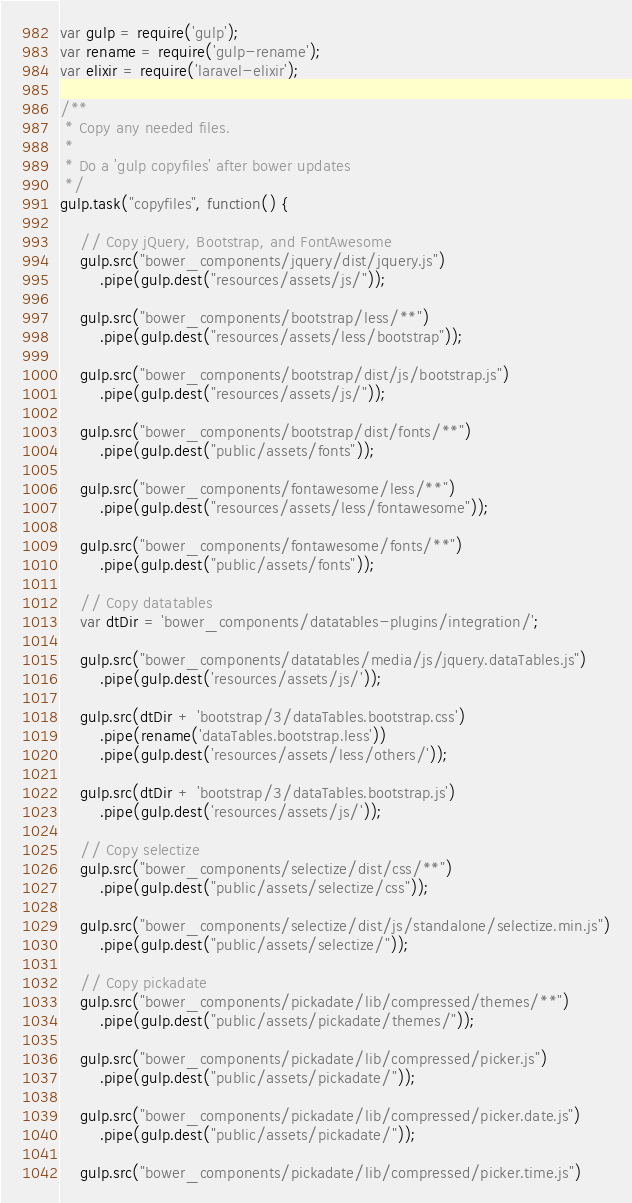Convert code to text. <code><loc_0><loc_0><loc_500><loc_500><_JavaScript_>var gulp = require('gulp');
var rename = require('gulp-rename');
var elixir = require('laravel-elixir');

/**
 * Copy any needed files.
 *
 * Do a 'gulp copyfiles' after bower updates
 */
gulp.task("copyfiles", function() {

    // Copy jQuery, Bootstrap, and FontAwesome
    gulp.src("bower_components/jquery/dist/jquery.js")
        .pipe(gulp.dest("resources/assets/js/"));

    gulp.src("bower_components/bootstrap/less/**")
        .pipe(gulp.dest("resources/assets/less/bootstrap"));

    gulp.src("bower_components/bootstrap/dist/js/bootstrap.js")
        .pipe(gulp.dest("resources/assets/js/"));

    gulp.src("bower_components/bootstrap/dist/fonts/**")
        .pipe(gulp.dest("public/assets/fonts"));

    gulp.src("bower_components/fontawesome/less/**")
        .pipe(gulp.dest("resources/assets/less/fontawesome"));

    gulp.src("bower_components/fontawesome/fonts/**")
        .pipe(gulp.dest("public/assets/fonts"));

    // Copy datatables
    var dtDir = 'bower_components/datatables-plugins/integration/';

    gulp.src("bower_components/datatables/media/js/jquery.dataTables.js")
        .pipe(gulp.dest('resources/assets/js/'));

    gulp.src(dtDir + 'bootstrap/3/dataTables.bootstrap.css')
        .pipe(rename('dataTables.bootstrap.less'))
        .pipe(gulp.dest('resources/assets/less/others/'));

    gulp.src(dtDir + 'bootstrap/3/dataTables.bootstrap.js')
        .pipe(gulp.dest('resources/assets/js/'));

    // Copy selectize
    gulp.src("bower_components/selectize/dist/css/**")
        .pipe(gulp.dest("public/assets/selectize/css"));

    gulp.src("bower_components/selectize/dist/js/standalone/selectize.min.js")
        .pipe(gulp.dest("public/assets/selectize/"));

    // Copy pickadate
    gulp.src("bower_components/pickadate/lib/compressed/themes/**")
        .pipe(gulp.dest("public/assets/pickadate/themes/"));

    gulp.src("bower_components/pickadate/lib/compressed/picker.js")
        .pipe(gulp.dest("public/assets/pickadate/"));

    gulp.src("bower_components/pickadate/lib/compressed/picker.date.js")
        .pipe(gulp.dest("public/assets/pickadate/"));

    gulp.src("bower_components/pickadate/lib/compressed/picker.time.js")</code> 